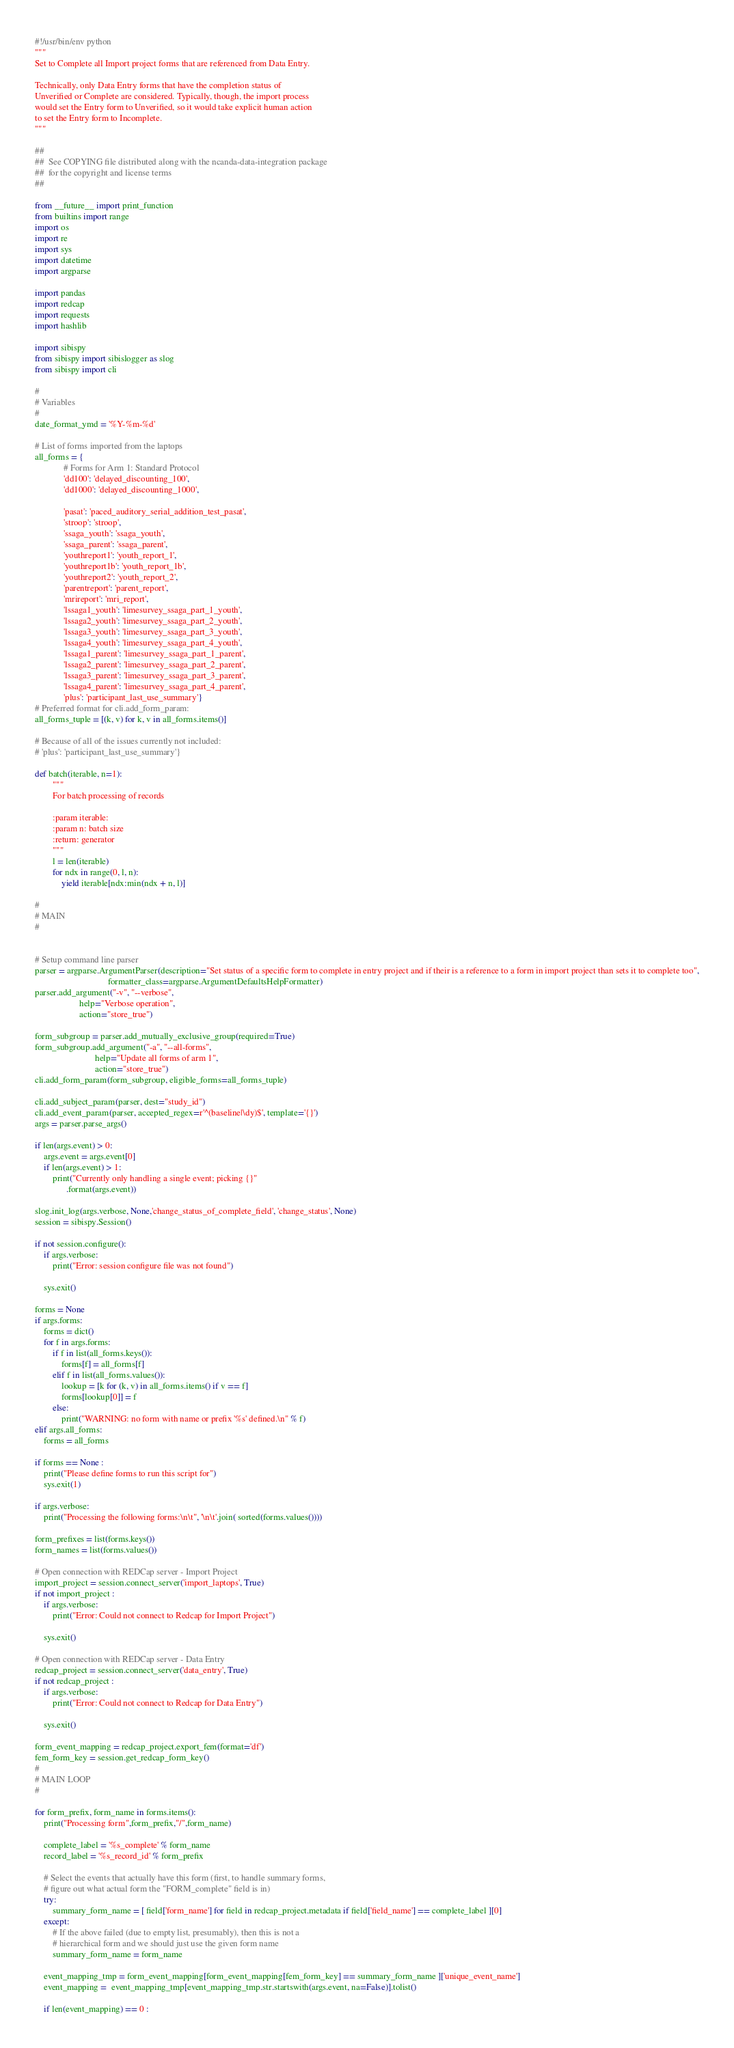<code> <loc_0><loc_0><loc_500><loc_500><_Python_>#!/usr/bin/env python
"""
Set to Complete all Import project forms that are referenced from Data Entry.

Technically, only Data Entry forms that have the completion status of
Unverified or Complete are considered. Typically, though, the import process
would set the Entry form to Unverified, so it would take explicit human action
to set the Entry form to Incomplete.
"""

##
##  See COPYING file distributed along with the ncanda-data-integration package
##  for the copyright and license terms
##

from __future__ import print_function
from builtins import range
import os
import re
import sys
import datetime
import argparse

import pandas
import redcap
import requests
import hashlib 

import sibispy
from sibispy import sibislogger as slog
from sibispy import cli

#
# Variables 
# 
date_format_ymd = '%Y-%m-%d'

# List of forms imported from the laptops
all_forms = {
             # Forms for Arm 1: Standard Protocol
             'dd100': 'delayed_discounting_100',
             'dd1000': 'delayed_discounting_1000',

             'pasat': 'paced_auditory_serial_addition_test_pasat',
             'stroop': 'stroop',
             'ssaga_youth': 'ssaga_youth',
             'ssaga_parent': 'ssaga_parent',
             'youthreport1': 'youth_report_1',
             'youthreport1b': 'youth_report_1b',
             'youthreport2': 'youth_report_2',
             'parentreport': 'parent_report',
             'mrireport': 'mri_report',
             'lssaga1_youth': 'limesurvey_ssaga_part_1_youth',
             'lssaga2_youth': 'limesurvey_ssaga_part_2_youth',
             'lssaga3_youth': 'limesurvey_ssaga_part_3_youth',
             'lssaga4_youth': 'limesurvey_ssaga_part_4_youth',
             'lssaga1_parent': 'limesurvey_ssaga_part_1_parent',
             'lssaga2_parent': 'limesurvey_ssaga_part_2_parent',
             'lssaga3_parent': 'limesurvey_ssaga_part_3_parent',
             'lssaga4_parent': 'limesurvey_ssaga_part_4_parent',
             'plus': 'participant_last_use_summary'}
# Preferred format for cli.add_form_param:
all_forms_tuple = [(k, v) for k, v in all_forms.items()]

# Because of all of the issues currently not included: 
# 'plus': 'participant_last_use_summary'}

def batch(iterable, n=1):
        """
        For batch processing of records

        :param iterable:
        :param n: batch size
        :return: generator
        """
        l = len(iterable)
        for ndx in range(0, l, n):
            yield iterable[ndx:min(ndx + n, l)]

#
# MAIN 
#


# Setup command line parser
parser = argparse.ArgumentParser(description="Set status of a specific form to complete in entry project and if their is a reference to a form in import project than sets it to complete too",
                                 formatter_class=argparse.ArgumentDefaultsHelpFormatter)
parser.add_argument("-v", "--verbose",
                    help="Verbose operation",
                    action="store_true")

form_subgroup = parser.add_mutually_exclusive_group(required=True)
form_subgroup.add_argument("-a", "--all-forms",
                           help="Update all forms of arm 1",
                           action="store_true")
cli.add_form_param(form_subgroup, eligible_forms=all_forms_tuple)

cli.add_subject_param(parser, dest="study_id")
cli.add_event_param(parser, accepted_regex=r'^(baseline|\dy)$', template='{}')
args = parser.parse_args()

if len(args.event) > 0:
    args.event = args.event[0]
    if len(args.event) > 1:
        print("Currently only handling a single event; picking {}"
              .format(args.event))

slog.init_log(args.verbose, None,'change_status_of_complete_field', 'change_status', None)
session = sibispy.Session()

if not session.configure():
    if args.verbose:
        print("Error: session configure file was not found")

    sys.exit()

forms = None
if args.forms:
    forms = dict()
    for f in args.forms:
        if f in list(all_forms.keys()):
            forms[f] = all_forms[f]
        elif f in list(all_forms.values()):
            lookup = [k for (k, v) in all_forms.items() if v == f]
            forms[lookup[0]] = f
        else:
            print("WARNING: no form with name or prefix '%s' defined.\n" % f)
elif args.all_forms:
    forms = all_forms

if forms == None : 
    print("Please define forms to run this script for") 
    sys.exit(1)

if args.verbose:
    print("Processing the following forms:\n\t", '\n\t'.join( sorted(forms.values())))

form_prefixes = list(forms.keys())
form_names = list(forms.values())

# Open connection with REDCap server - Import Project
import_project = session.connect_server('import_laptops', True)
if not import_project :
    if args.verbose:
        print("Error: Could not connect to Redcap for Import Project")

    sys.exit()

# Open connection with REDCap server - Data Entry
redcap_project = session.connect_server('data_entry', True)
if not redcap_project :
    if args.verbose:
        print("Error: Could not connect to Redcap for Data Entry")

    sys.exit()

form_event_mapping = redcap_project.export_fem(format='df')
fem_form_key = session.get_redcap_form_key()
#
# MAIN LOOP
#

for form_prefix, form_name in forms.items():
    print("Processing form",form_prefix,"/",form_name)

    complete_label = '%s_complete' % form_name
    record_label = '%s_record_id' % form_prefix 

    # Select the events that actually have this form (first, to handle summary forms,
    # figure out what actual form the "FORM_complete" field is in)
    try:
        summary_form_name = [ field['form_name'] for field in redcap_project.metadata if field['field_name'] == complete_label ][0]
    except:
        # If the above failed (due to empty list, presumably), then this is not a
        # hierarchical form and we should just use the given form name
        summary_form_name = form_name

    event_mapping_tmp = form_event_mapping[form_event_mapping[fem_form_key] == summary_form_name ]['unique_event_name']
    event_mapping =  event_mapping_tmp[event_mapping_tmp.str.startswith(args.event, na=False)].tolist()

    if len(event_mapping) == 0 : </code> 